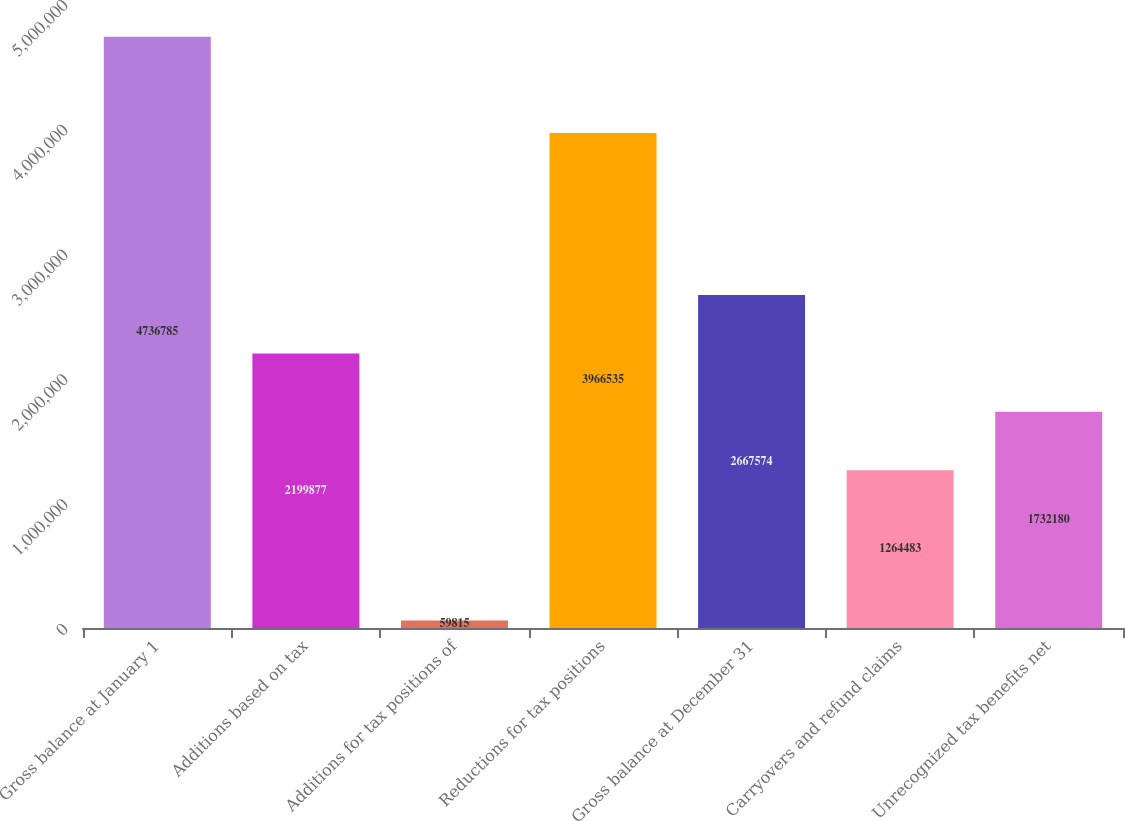Convert chart to OTSL. <chart><loc_0><loc_0><loc_500><loc_500><bar_chart><fcel>Gross balance at January 1<fcel>Additions based on tax<fcel>Additions for tax positions of<fcel>Reductions for tax positions<fcel>Gross balance at December 31<fcel>Carryovers and refund claims<fcel>Unrecognized tax benefits net<nl><fcel>4.73678e+06<fcel>2.19988e+06<fcel>59815<fcel>3.96654e+06<fcel>2.66757e+06<fcel>1.26448e+06<fcel>1.73218e+06<nl></chart> 